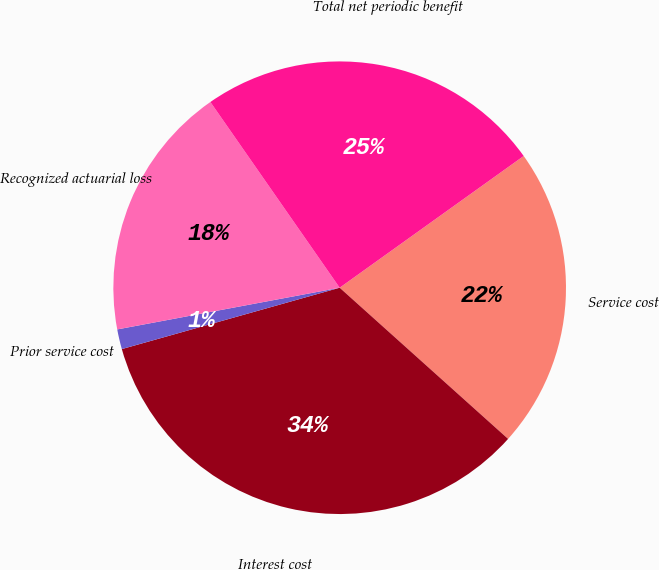<chart> <loc_0><loc_0><loc_500><loc_500><pie_chart><fcel>Service cost<fcel>Interest cost<fcel>Prior service cost<fcel>Recognized actuarial loss<fcel>Total net periodic benefit<nl><fcel>21.53%<fcel>33.99%<fcel>1.42%<fcel>18.27%<fcel>24.79%<nl></chart> 